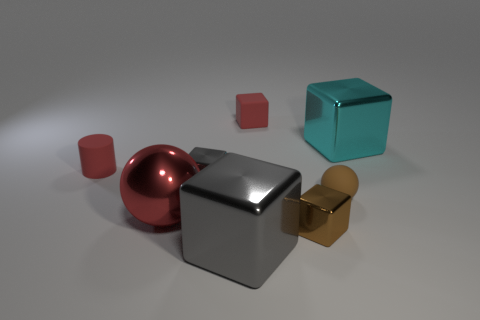There is a tiny gray metallic object; is its shape the same as the red rubber object on the right side of the red sphere?
Keep it short and to the point. Yes. What is the shape of the big cyan metallic object?
Provide a succinct answer. Cube. There is a cylinder that is the same size as the red cube; what material is it?
Your answer should be compact. Rubber. Is there anything else that is the same size as the rubber block?
Give a very brief answer. Yes. How many things are either tiny spheres or small objects to the left of the small ball?
Your answer should be very brief. 5. What is the size of the ball that is the same material as the cyan thing?
Your answer should be very brief. Large. There is a tiny red object behind the metal block to the right of the tiny ball; what is its shape?
Offer a very short reply. Cube. There is a red thing that is both behind the small gray metal thing and left of the big gray shiny thing; what size is it?
Offer a terse response. Small. Are there any tiny brown matte things of the same shape as the big red object?
Keep it short and to the point. Yes. There is a gray cube that is behind the ball on the left side of the tiny brown thing that is to the right of the small brown shiny thing; what is it made of?
Keep it short and to the point. Metal. 